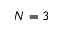Convert formula to latex. <formula><loc_0><loc_0><loc_500><loc_500>N = 3</formula> 